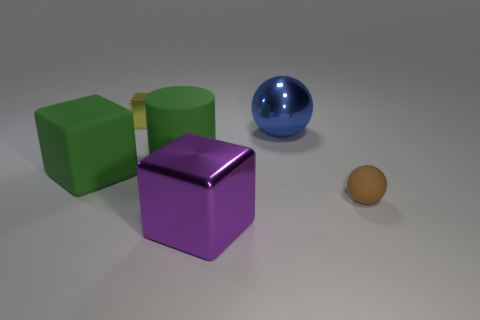What shape is the matte thing that is the same color as the cylinder?
Provide a short and direct response. Cube. Is there a big metal sphere that has the same color as the small metal thing?
Your answer should be very brief. No. What is the cylinder made of?
Your response must be concise. Rubber. How many gray metal spheres are there?
Provide a short and direct response. 0. Do the large block that is on the left side of the small yellow metallic object and the big rubber object that is on the right side of the tiny yellow shiny thing have the same color?
Give a very brief answer. Yes. The cylinder that is the same color as the matte block is what size?
Offer a terse response. Large. How many other objects are the same size as the yellow metal block?
Provide a succinct answer. 1. There is a cube that is behind the blue sphere; what color is it?
Keep it short and to the point. Yellow. Does the large cube that is in front of the big green block have the same material as the tiny yellow cube?
Provide a short and direct response. Yes. How many tiny things are behind the big rubber cube and right of the large purple thing?
Offer a very short reply. 0. 